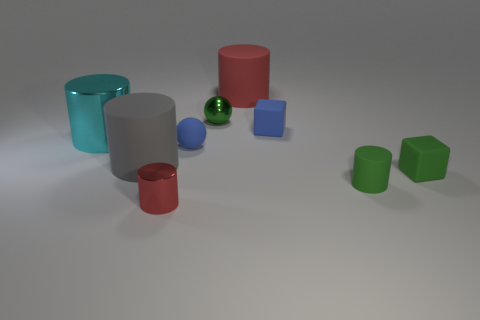Subtract 1 cylinders. How many cylinders are left? 4 Subtract all green cylinders. How many cylinders are left? 4 Subtract all green cylinders. How many cylinders are left? 4 Subtract all yellow cylinders. Subtract all cyan blocks. How many cylinders are left? 5 Add 1 small blue balls. How many objects exist? 10 Subtract all blocks. How many objects are left? 7 Subtract 0 purple spheres. How many objects are left? 9 Subtract all blue objects. Subtract all big gray matte things. How many objects are left? 6 Add 6 blocks. How many blocks are left? 8 Add 8 large red rubber cubes. How many large red rubber cubes exist? 8 